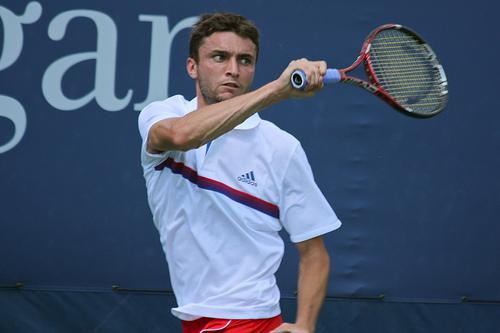Question: where is the racquet?
Choices:
A. In the man's left hand.
B. In the man's right hand.
C. In the woman's right hand.
D. Tied to the man's right foot.
Answer with the letter. Answer: B Question: why is the man holding a racquet?
Choices:
A. Weapon.
B. Playing tennis.
C. Prop.
D. Playing badminton.
Answer with the letter. Answer: B Question: what game is being played?
Choices:
A. Tennis.
B. Racquetball.
C. Badminton.
D. Volleyball.
Answer with the letter. Answer: A Question: who is holding the racquet?
Choices:
A. Woman.
B. Little boy.
C. Man.
D. Monkey.
Answer with the letter. Answer: C Question: how many people are there?
Choices:
A. 1.
B. 2.
C. 3.
D. 5.
Answer with the letter. Answer: A 